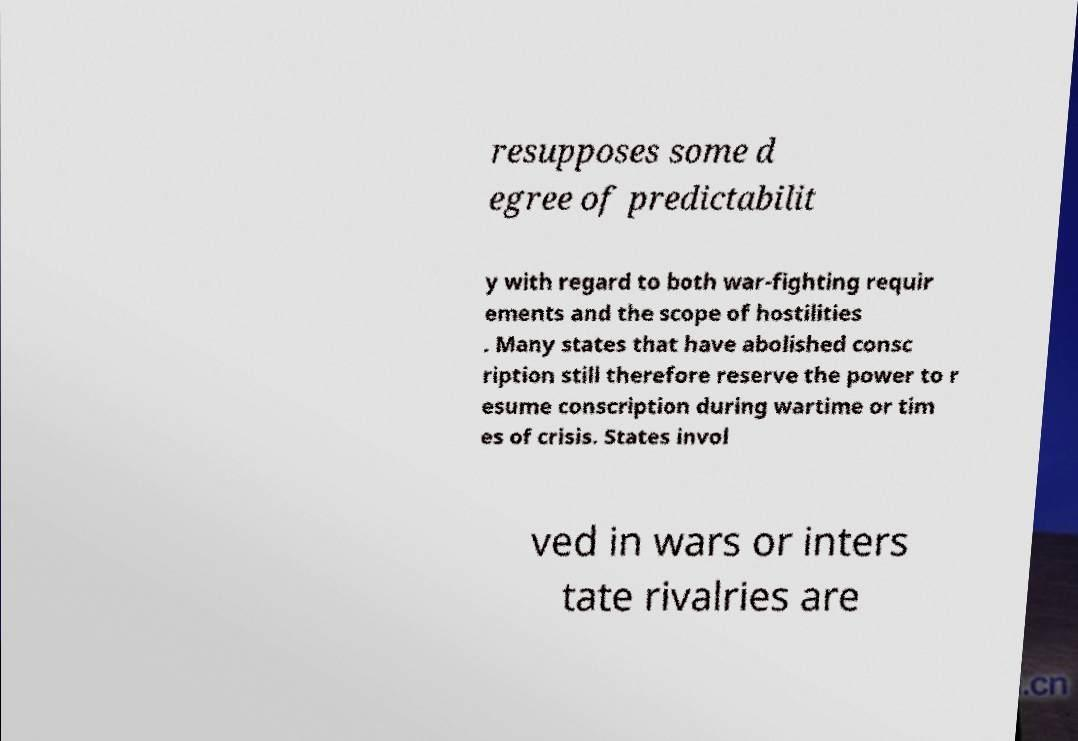Could you assist in decoding the text presented in this image and type it out clearly? resupposes some d egree of predictabilit y with regard to both war-fighting requir ements and the scope of hostilities . Many states that have abolished consc ription still therefore reserve the power to r esume conscription during wartime or tim es of crisis. States invol ved in wars or inters tate rivalries are 